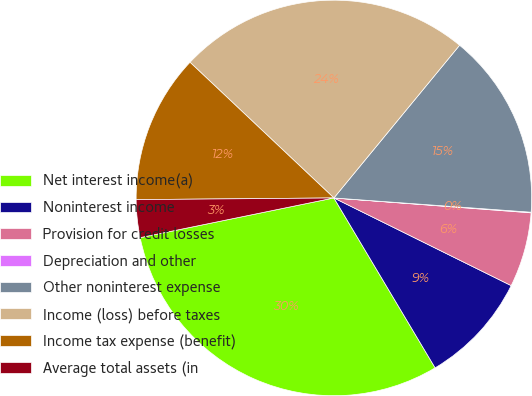<chart> <loc_0><loc_0><loc_500><loc_500><pie_chart><fcel>Net interest income(a)<fcel>Noninterest income<fcel>Provision for credit losses<fcel>Depreciation and other<fcel>Other noninterest expense<fcel>Income (loss) before taxes<fcel>Income tax expense (benefit)<fcel>Average total assets (in<nl><fcel>30.34%<fcel>9.14%<fcel>6.11%<fcel>0.05%<fcel>15.19%<fcel>23.93%<fcel>12.17%<fcel>3.08%<nl></chart> 